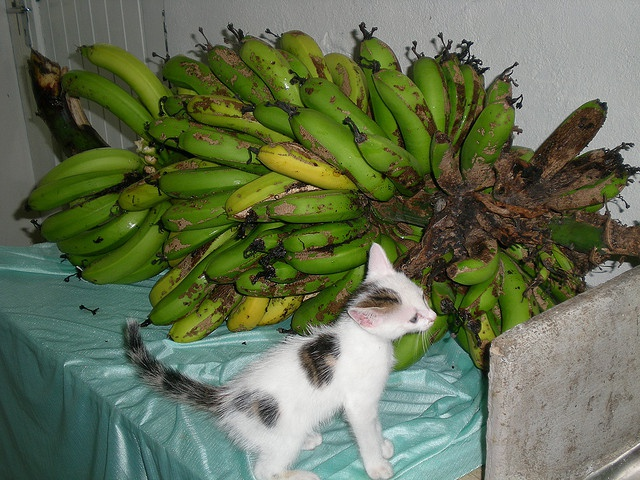Describe the objects in this image and their specific colors. I can see banana in gray, darkgreen, black, and olive tones and cat in gray, lightgray, darkgray, and black tones in this image. 